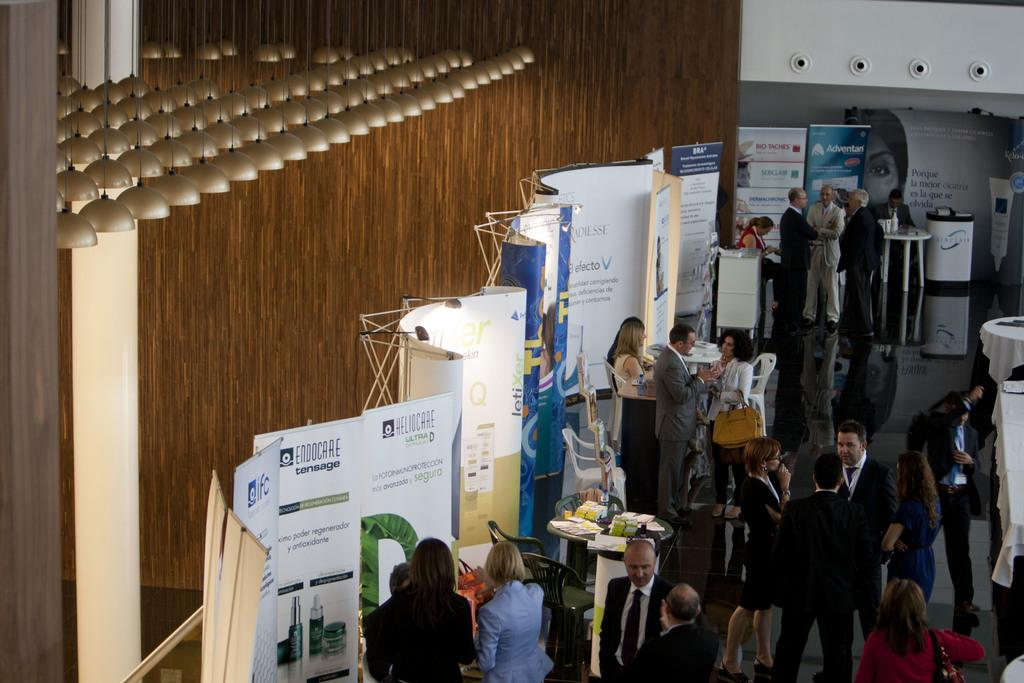What can be seen on the right side of the image? There are people on the right side of the image. What is located on the left side of the image? There are posters on the left side of the image. Where are the lights positioned in the image? The lights are in the top left side of the image. What is the name of the person in the image? There is no specific person mentioned in the image, so it is not possible to determine their name. Can you tell me which ear the person is using to listen to music in the image? There is no indication that anyone is listening to music in the image, so it is not possible to determine which ear they might be using. 